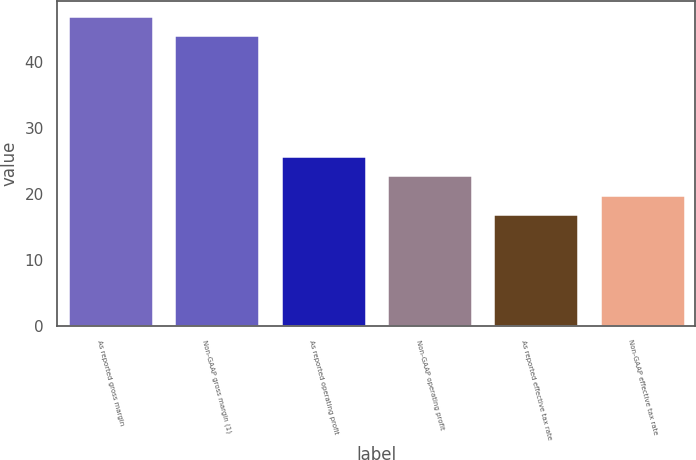Convert chart. <chart><loc_0><loc_0><loc_500><loc_500><bar_chart><fcel>As reported gross margin<fcel>Non-GAAP gross margin (1)<fcel>As reported operating profit<fcel>Non-GAAP operating profit<fcel>As reported effective tax rate<fcel>Non-GAAP effective tax rate<nl><fcel>46.89<fcel>44<fcel>25.67<fcel>22.78<fcel>17<fcel>19.89<nl></chart> 